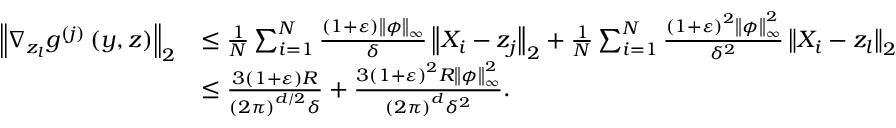Convert formula to latex. <formula><loc_0><loc_0><loc_500><loc_500>\begin{array} { r l } { \left \| \nabla _ { z _ { l } } g ^ { ( j ) } \left ( y , z \right ) \right \| _ { 2 } } & { \leq \frac { 1 } { N } \sum _ { i = 1 } ^ { N } \frac { \left ( 1 + \varepsilon \right ) \left \| \phi \right \| _ { \infty } } { \delta } \left \| X _ { i } - z _ { j } \right \| _ { 2 } + \frac { 1 } { N } \sum _ { i = 1 } ^ { N } \frac { \left ( 1 + \varepsilon \right ) ^ { 2 } \left \| \phi \right \| _ { \infty } ^ { 2 } } { \delta ^ { 2 } } \left \| X _ { i } - z _ { l } \right \| _ { 2 } } \\ & { \leq \frac { 3 \left ( 1 + \varepsilon \right ) R } { \left ( 2 \pi \right ) ^ { d / 2 } \delta } + \frac { 3 \left ( 1 + \varepsilon \right ) ^ { 2 } R \left \| \phi \right \| _ { \infty } ^ { 2 } } { \left ( 2 \pi \right ) ^ { d } \delta ^ { 2 } } . } \end{array}</formula> 